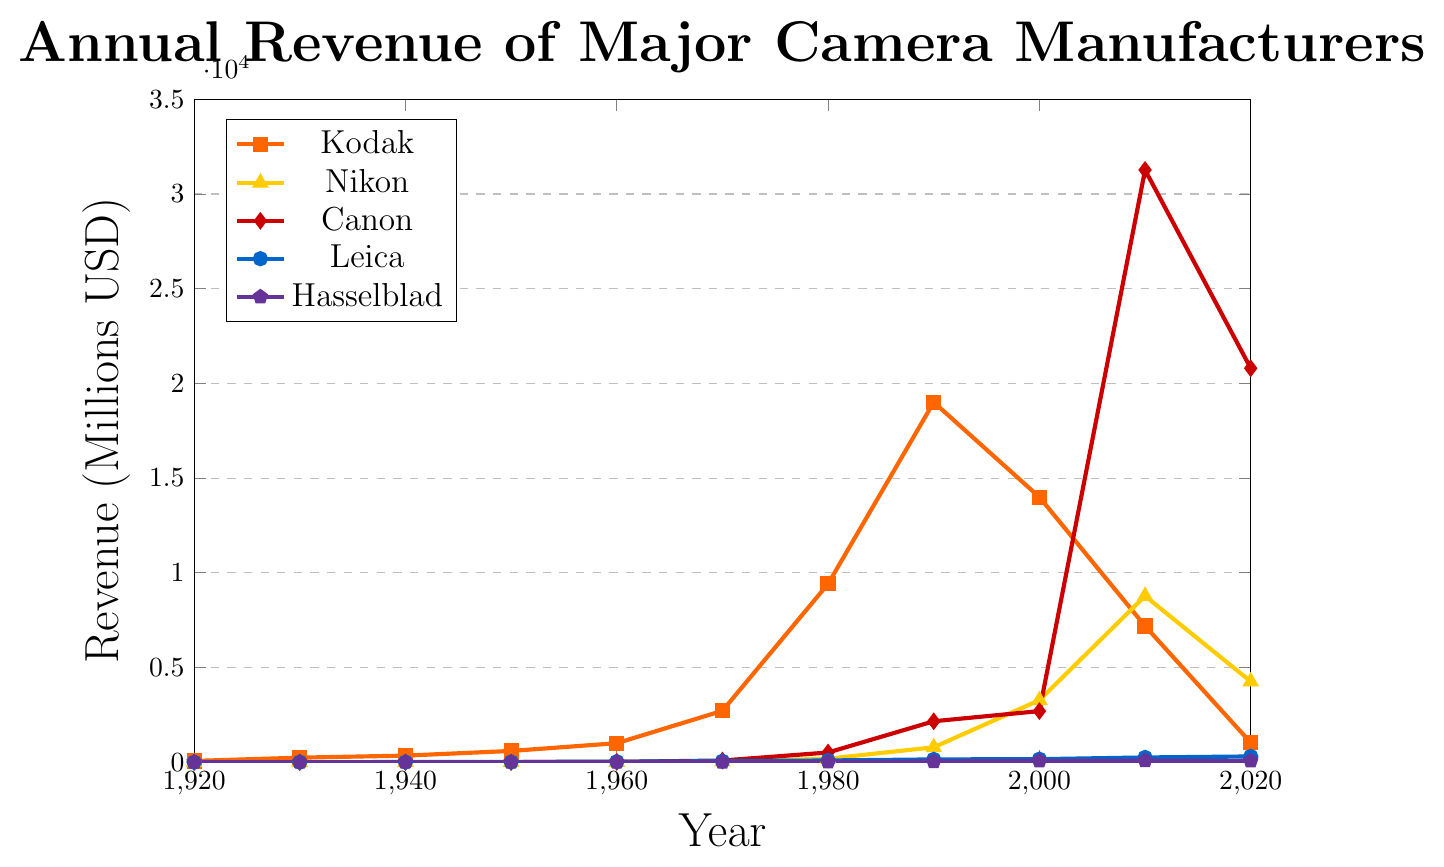What was Kodak's highest annual revenue and in which year did it occur? Look at the peak of Kodak's line on the chart, which is colored orange, and note the highest point. The highest revenue value is approximately 19005 in 1990.
Answer: 19005 in 1990 How does Canon's revenue in 2010 compare to its revenue in 2000? Check Canon's red line for the values in 2000 and 2010. In 2000, it's approximately 2696 and in 2010, it's roughly 31268. Subtract the 2000 value from the 2010 value: 31268 - 2696 = 28572. Canon's revenue increased by 28572.
Answer: Increased by 28572 What is the total revenue for Leica over the century? Sum up the revenues for Leica, represented by the blue line, across all the years. Adding the values: 1 + 3 + 5 + 12 + 25 + 52 + 89 + 145 + 158 + 248 + 301 = 1039.
Answer: 1039 Which company had the steepest increase in revenue between 1990 and 2000? Look for the sharpest incline between 1990 and 2000. Canon's line (red) looks the steepest. The difference is: 2696 - 2160 = 536. Nikon has 3274 - 785 = 2489. Comparing these, Nikon had a steeper increase.
Answer: Nikon How many companies had revenue exceeding 10000 in 2010? Identify the revenue values for 2010 and count the companies with values exceeding 10000. Canon (31268) and Nikon (8774) are the two companies meeting this criterion.
Answer: 2 What is the average revenue of Hasselblad from 1980 to 2020? Add Hasselblad's revenues for 1980 (15), 1990 (35), 2000 (68), 2010 (78), and 2020 (65), and then divide by the number of years (5). (15 + 35 + 68 + 78 + 65) / 5 = 52.2
Answer: 52.2 Which manufacturer had the most consistent growth over the century? Observing the lines, Leica's line (blue) appears to rise steadily without sharp spikes or drops.
Answer: Leica Between 1960 and 1970, which company saw the largest relative growth in revenue? Check the change in revenue from 1960 to 1970. Canon went from 15 to 87, an increase of 72. Nikon from 8 to 32, an increase of 24. Calculate the relative growth: Canon - (87 - 15)/15 = 4.8, Nikon (32 - 8)/8 = 3. Therefore, Canon had the largest relative growth.
Answer: Canon What were the approximate revenues for each company in 1920? Refer to the starting points of each line in 1920: Kodak (65), Nikon (0), Canon (0), Leica (1), Hasselblad (0). Summarize these results.
Answer: Kodak: 65, Nikon: 0, Canon: 0, Leica: 1, Hasselblad: 0 